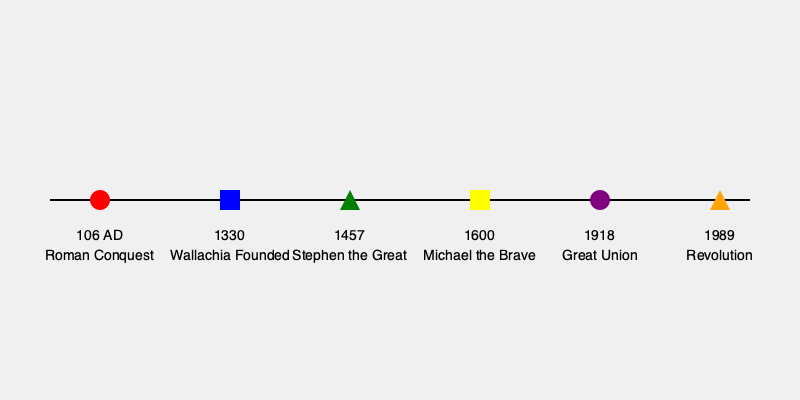Which historical event is represented by the yellow square on the timeline, and what was its significance in Romanian history? To answer this question, let's analyze the timeline step-by-step:

1. The timeline shows major events in Romanian history, each represented by a different shape and color.

2. The yellow square is positioned at the year 1600 on the timeline.

3. The event associated with this year is labeled "Michael the Brave."

4. Michael the Brave (Mihai Viteazul in Romanian) was a significant figure in Romanian history for the following reasons:

   a. He was the Prince of Wallachia, Transylvania, and Moldavia.
   b. In 1600, he united the three principalities under a single rule for the first time.
   c. This brief unification is considered a precursor to the modern state of Romania.
   d. His actions are seen as the first steps towards Romanian national unity.

5. Although the unification was short-lived (lasting only about a year), it became a symbol of Romanian nationalism and a source of inspiration for future generations.

6. This event is particularly significant as it represents the first time the territories that would later form modern Romania were united under a single Romanian ruler.

Therefore, the yellow square represents Michael the Brave's unification of Wallachia, Transylvania, and Moldavia in 1600, a pivotal moment in the development of Romanian national identity and a precursor to the modern Romanian state.
Answer: Michael the Brave's unification of Romanian principalities in 1600 